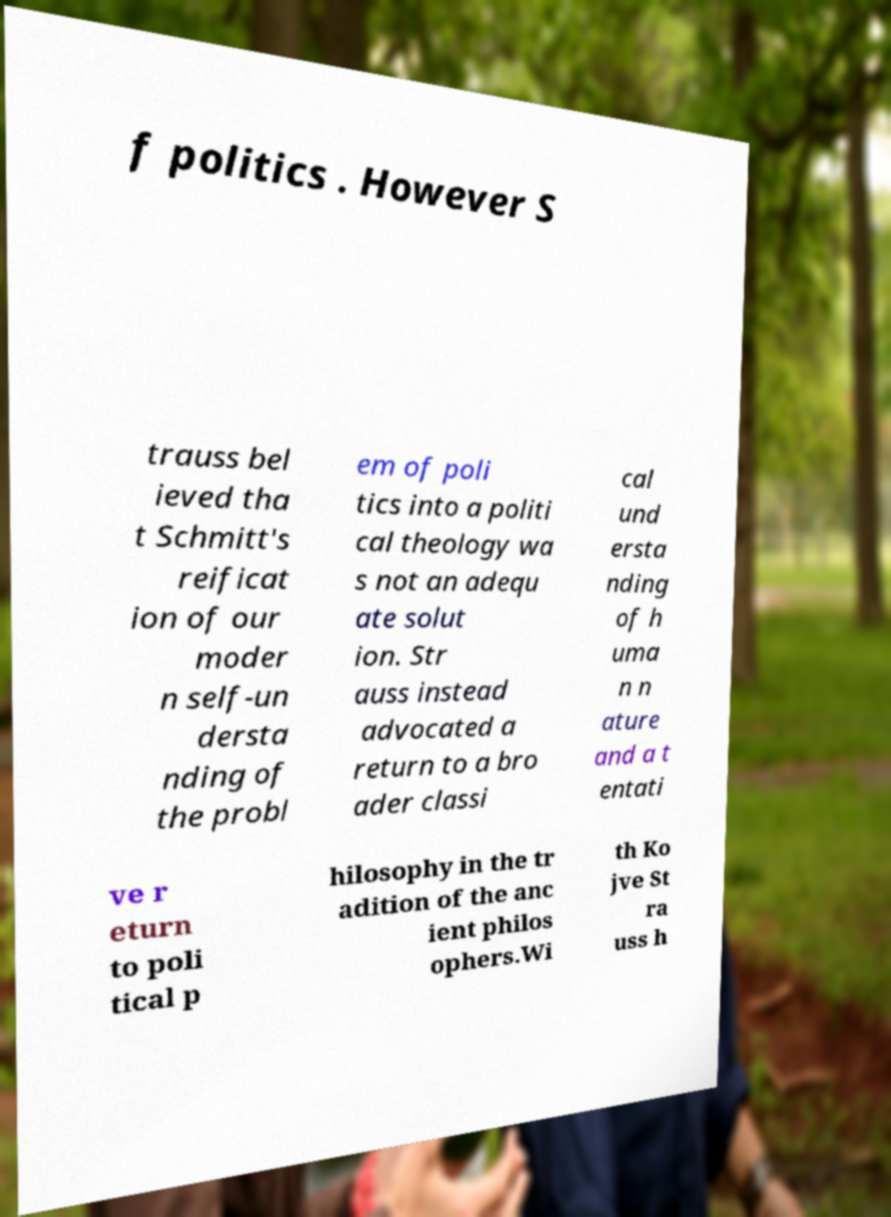Could you assist in decoding the text presented in this image and type it out clearly? f politics . However S trauss bel ieved tha t Schmitt's reificat ion of our moder n self-un dersta nding of the probl em of poli tics into a politi cal theology wa s not an adequ ate solut ion. Str auss instead advocated a return to a bro ader classi cal und ersta nding of h uma n n ature and a t entati ve r eturn to poli tical p hilosophy in the tr adition of the anc ient philos ophers.Wi th Ko jve St ra uss h 